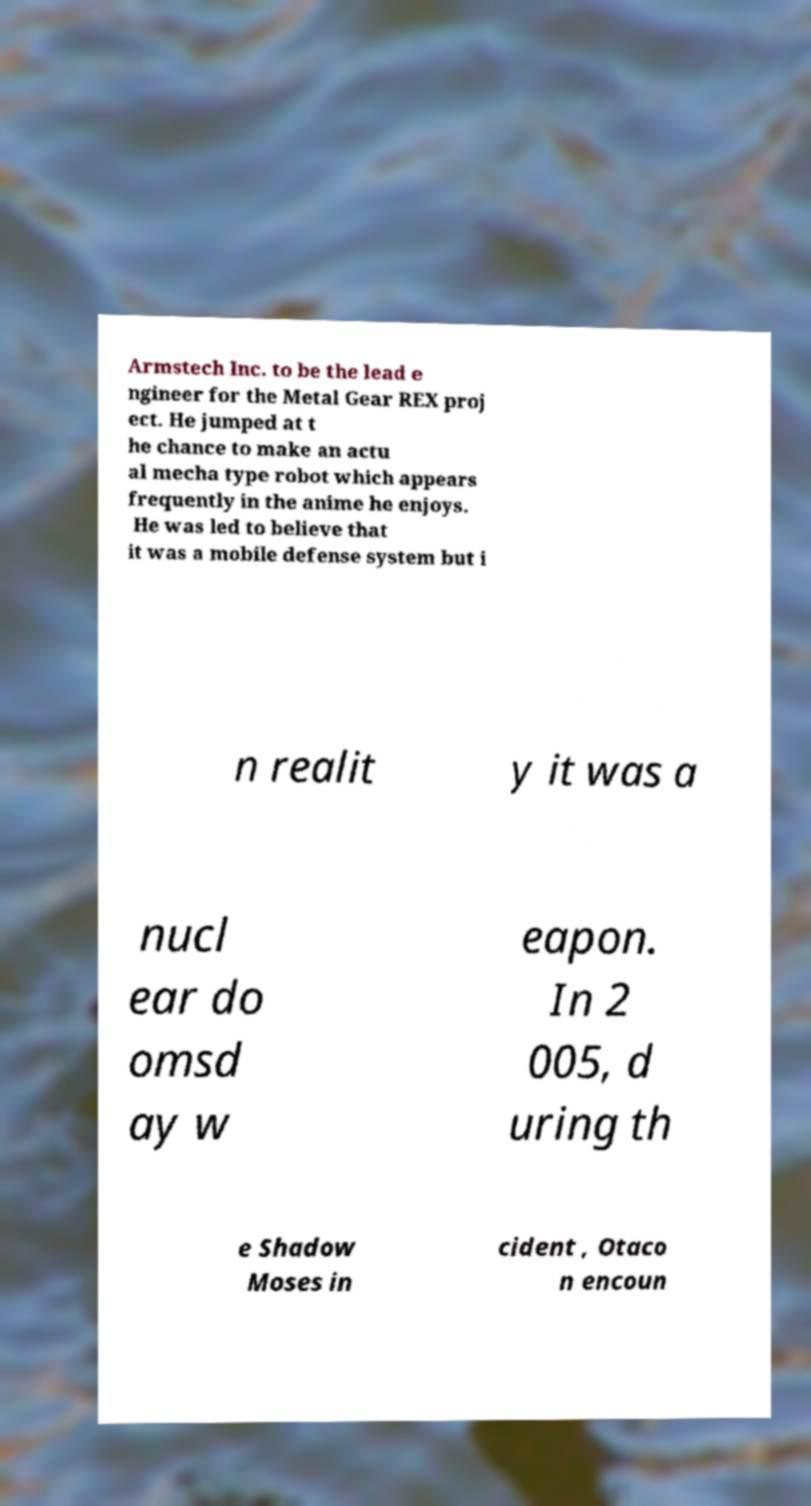For documentation purposes, I need the text within this image transcribed. Could you provide that? Armstech Inc. to be the lead e ngineer for the Metal Gear REX proj ect. He jumped at t he chance to make an actu al mecha type robot which appears frequently in the anime he enjoys. He was led to believe that it was a mobile defense system but i n realit y it was a nucl ear do omsd ay w eapon. In 2 005, d uring th e Shadow Moses in cident , Otaco n encoun 